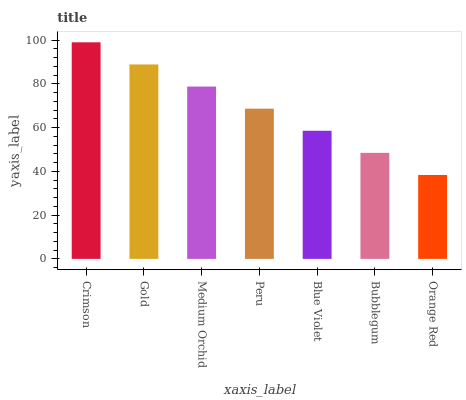Is Orange Red the minimum?
Answer yes or no. Yes. Is Crimson the maximum?
Answer yes or no. Yes. Is Gold the minimum?
Answer yes or no. No. Is Gold the maximum?
Answer yes or no. No. Is Crimson greater than Gold?
Answer yes or no. Yes. Is Gold less than Crimson?
Answer yes or no. Yes. Is Gold greater than Crimson?
Answer yes or no. No. Is Crimson less than Gold?
Answer yes or no. No. Is Peru the high median?
Answer yes or no. Yes. Is Peru the low median?
Answer yes or no. Yes. Is Crimson the high median?
Answer yes or no. No. Is Gold the low median?
Answer yes or no. No. 